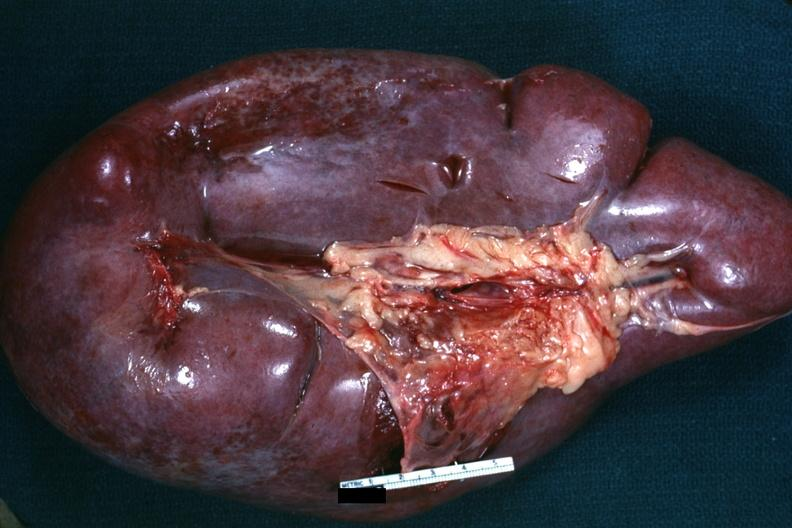what is present?
Answer the question using a single word or phrase. Acute myelogenous leukemia 